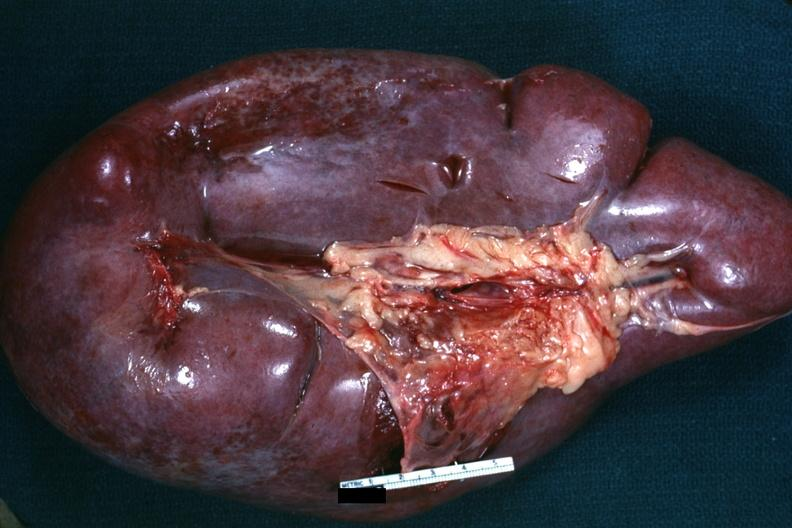what is present?
Answer the question using a single word or phrase. Acute myelogenous leukemia 